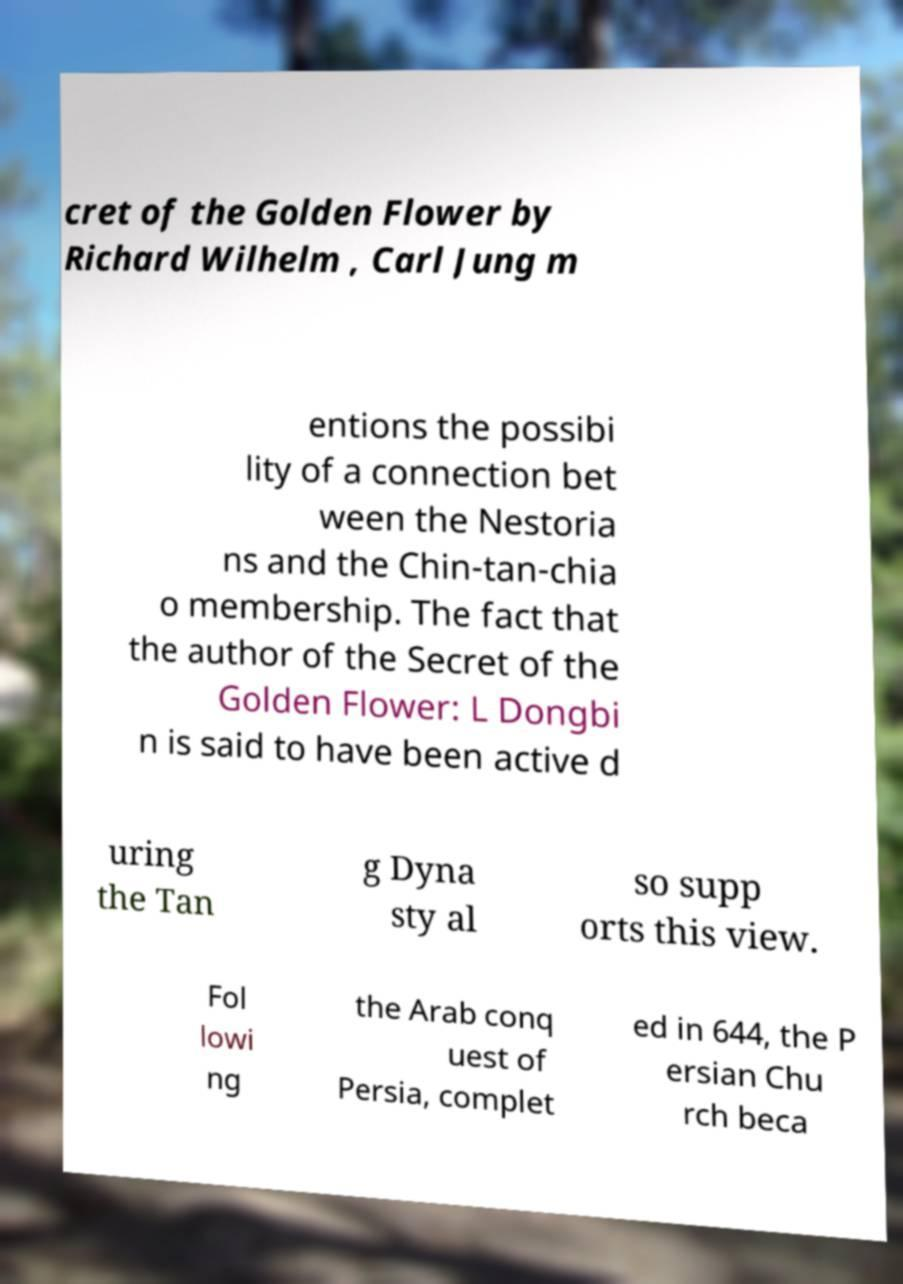There's text embedded in this image that I need extracted. Can you transcribe it verbatim? cret of the Golden Flower by Richard Wilhelm , Carl Jung m entions the possibi lity of a connection bet ween the Nestoria ns and the Chin-tan-chia o membership. The fact that the author of the Secret of the Golden Flower: L Dongbi n is said to have been active d uring the Tan g Dyna sty al so supp orts this view. Fol lowi ng the Arab conq uest of Persia, complet ed in 644, the P ersian Chu rch beca 